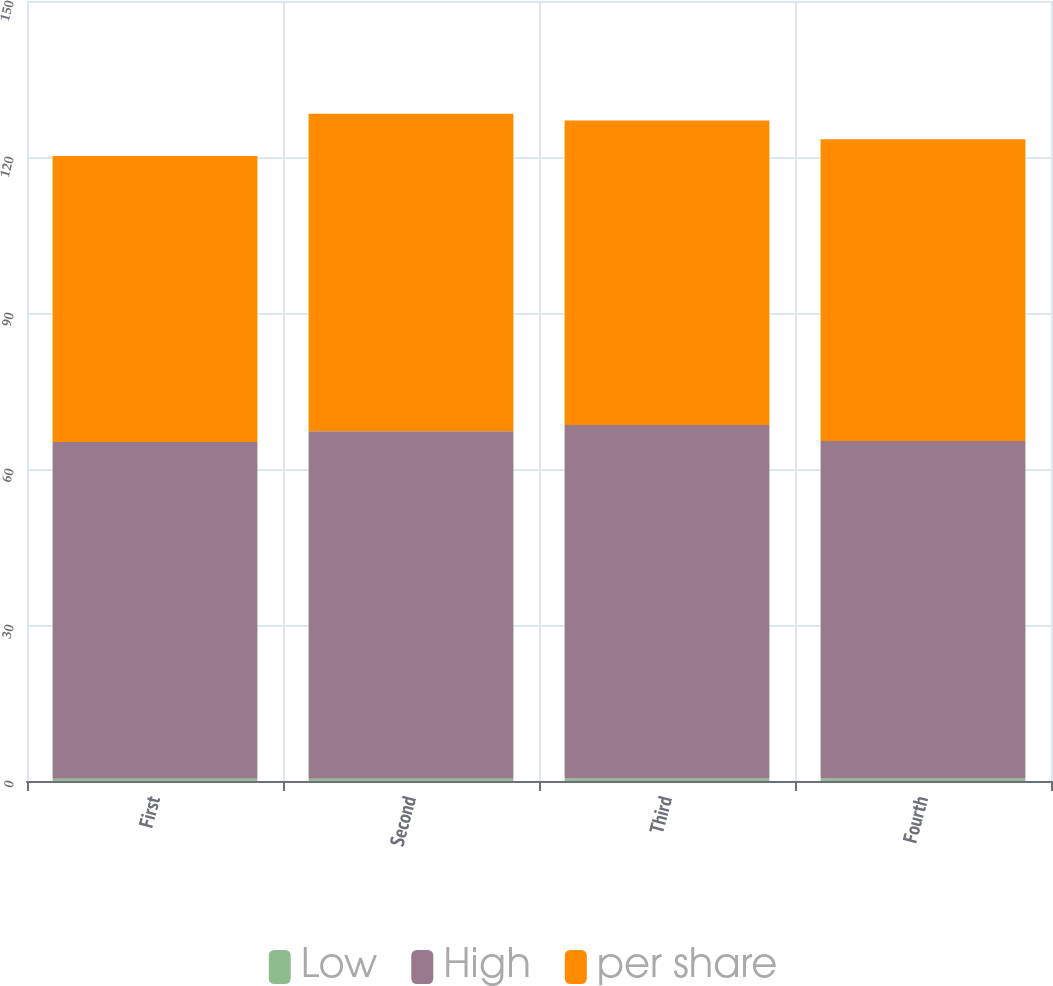Convert chart to OTSL. <chart><loc_0><loc_0><loc_500><loc_500><stacked_bar_chart><ecel><fcel>First<fcel>Second<fcel>Third<fcel>Fourth<nl><fcel>Low<fcel>0.44<fcel>0.44<fcel>0.46<fcel>0.46<nl><fcel>High<fcel>64.75<fcel>66.84<fcel>67.98<fcel>64.92<nl><fcel>per share<fcel>55.02<fcel>61.03<fcel>58.59<fcel>58.01<nl></chart> 